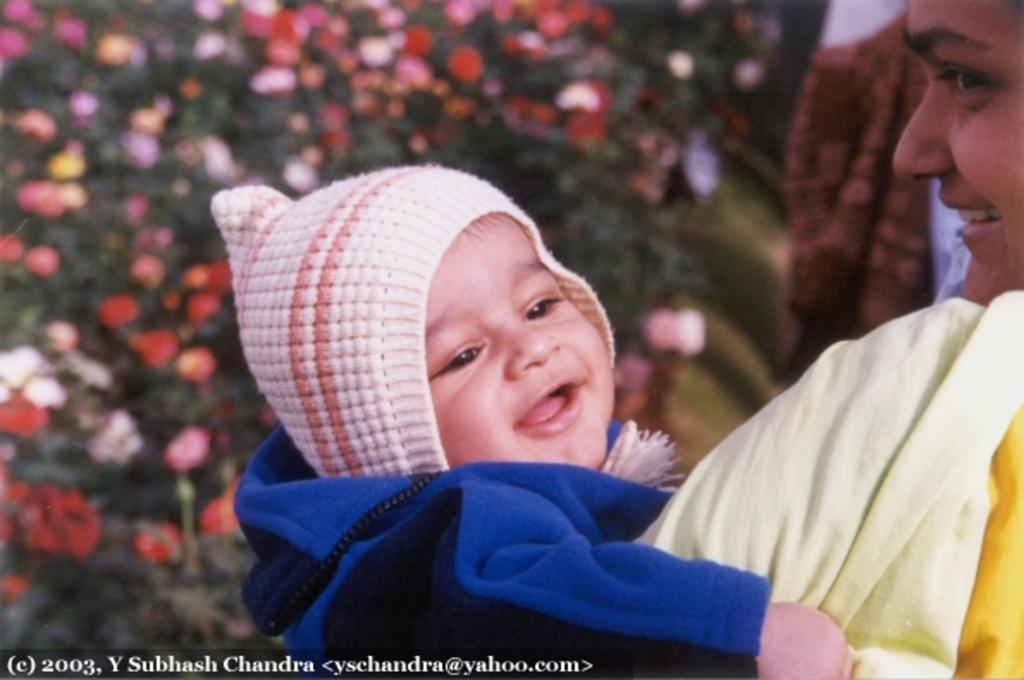Who is the main subject in the image? There is a woman in the image. What is the woman doing in the image? The woman is holding a baby. How is the baby positioned in relation to the woman? The baby is in the woman's arms. What is the baby wearing in the image? The baby is wearing a cap. What can be seen in the background of the image? There are plants with flowers and leaves in the background. What is present at the bottom of the image? There is some text at the bottom of the image. Reasoning: Let's think step by step by step in order to produce the conversation. We start by identifying the main subject in the image, which is the woman. Then, we describe her actions and the position of the baby. We also mention the baby's clothing and the background elements. Finally, we acknowledge the presence of text at the bottom of the image. Absurd Question/Answer: Can you see a rifle in the woman's hands in the image? No, there is no rifle present in the image. What type of branch is the baby holding in the image? There is no branch present in the image; the baby is wearing a cap and is in the woman's arms. Can you see a rifle in the woman's hands in the image? No, there is no rifle present in the image. What type of branch is the baby holding in the image? There is no branch present in the image; the baby is wearing a cap and is in the woman's arms. 